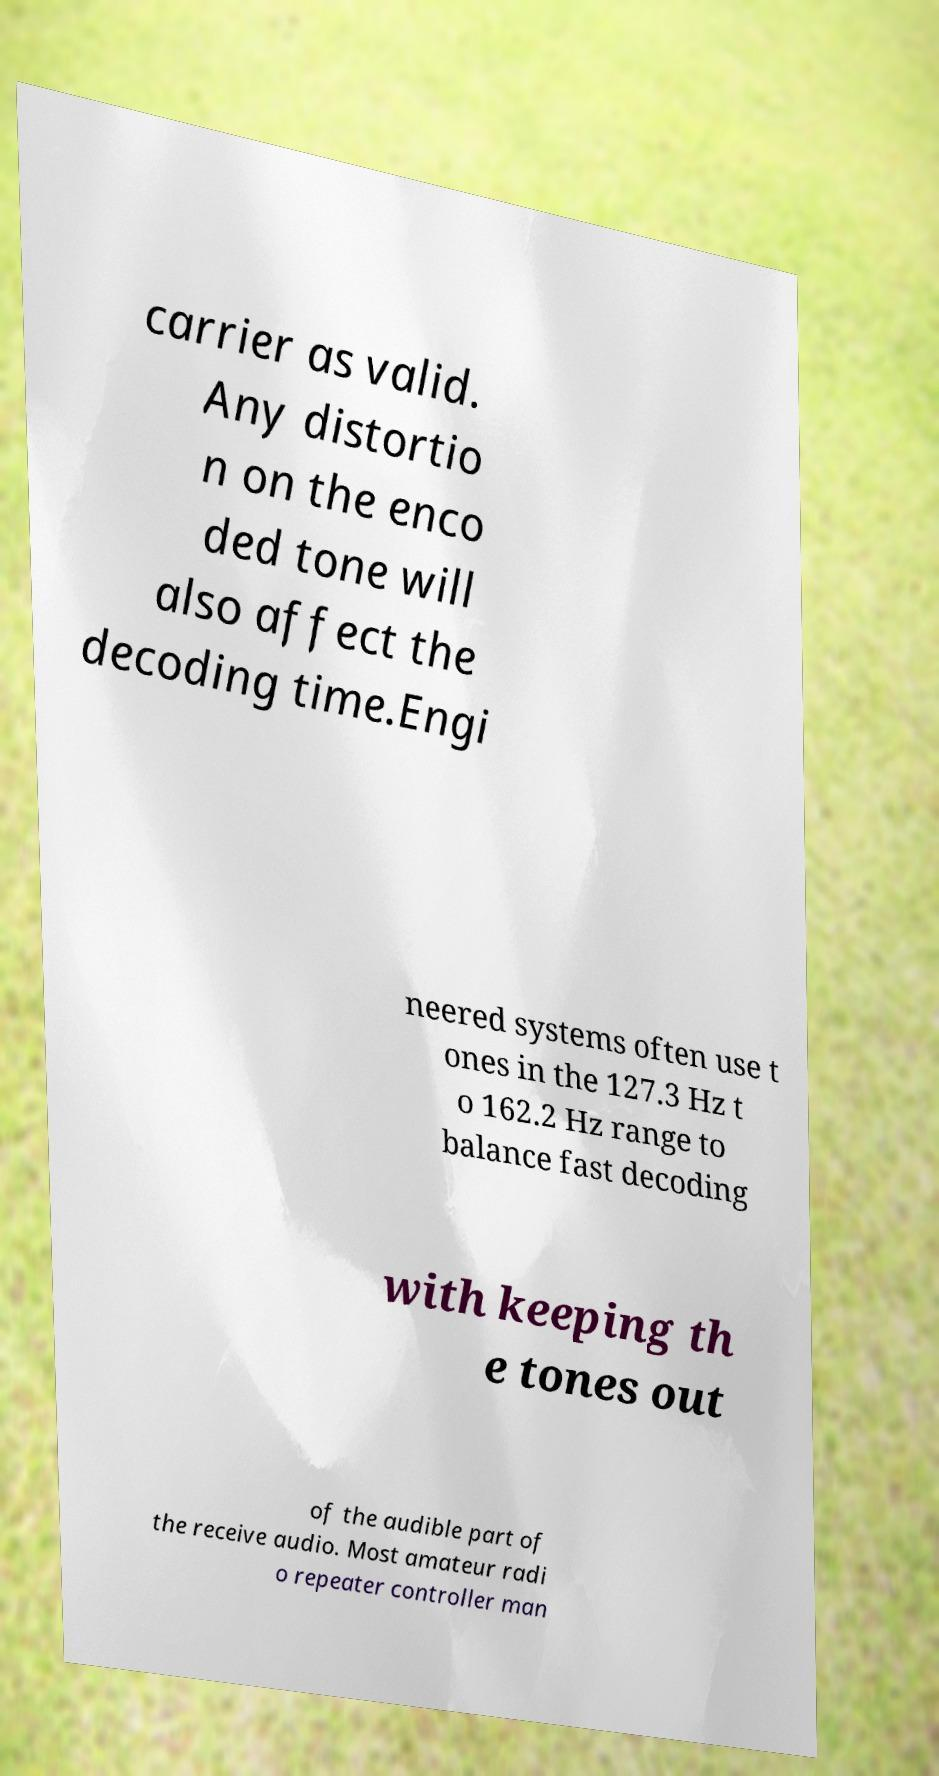Could you assist in decoding the text presented in this image and type it out clearly? carrier as valid. Any distortio n on the enco ded tone will also affect the decoding time.Engi neered systems often use t ones in the 127.3 Hz t o 162.2 Hz range to balance fast decoding with keeping th e tones out of the audible part of the receive audio. Most amateur radi o repeater controller man 